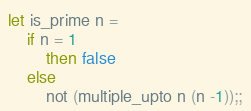<code> <loc_0><loc_0><loc_500><loc_500><_OCaml_>let is_prime n =
    if n = 1
        then false
    else
        not (multiple_upto n (n -1));;</code> 